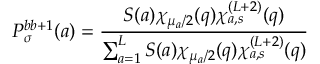<formula> <loc_0><loc_0><loc_500><loc_500>P _ { \sigma } ^ { b b + 1 } ( a ) = \frac { S ( a ) \chi _ { \mu _ { a } / 2 } ( q ) \chi _ { a , s } ^ { ( L + 2 ) } ( q ) } { \sum _ { a = 1 } ^ { L } S ( a ) \chi _ { \mu _ { a } / 2 } ( q ) \chi _ { a , s } ^ { ( L + 2 ) } ( q ) }</formula> 